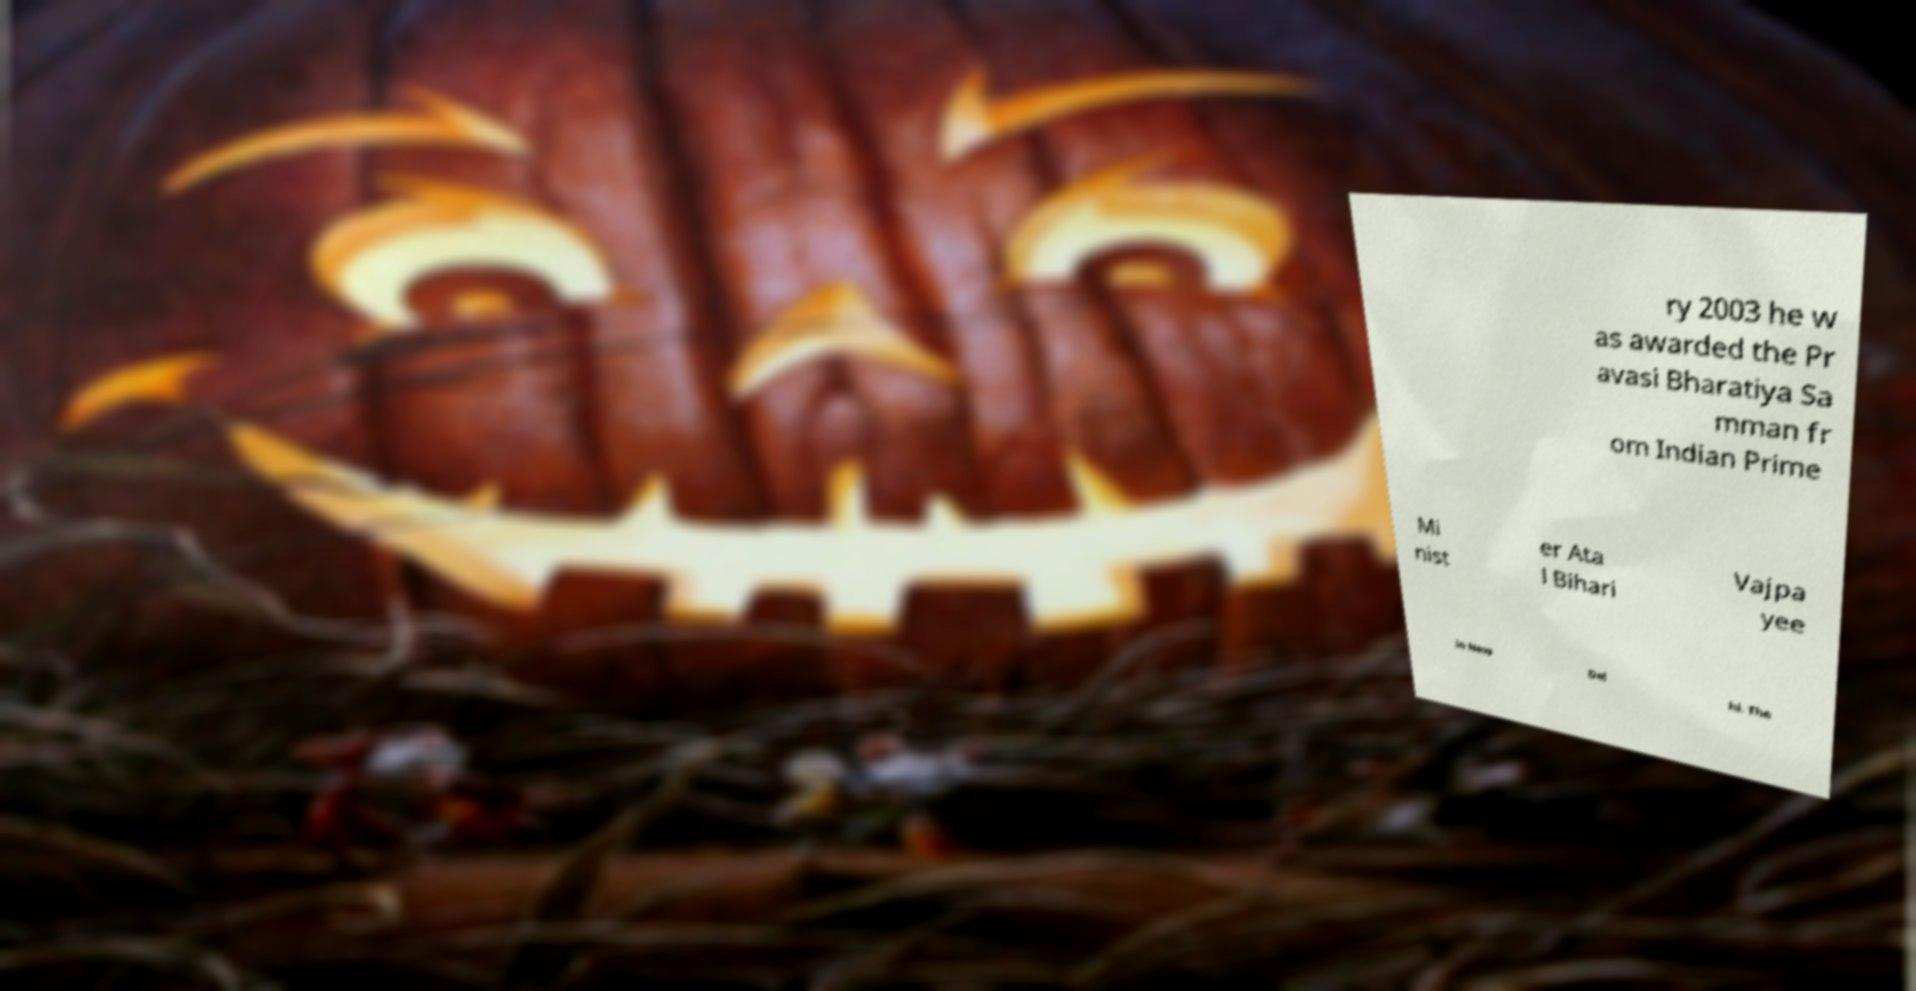Can you read and provide the text displayed in the image?This photo seems to have some interesting text. Can you extract and type it out for me? ry 2003 he w as awarded the Pr avasi Bharatiya Sa mman fr om Indian Prime Mi nist er Ata l Bihari Vajpa yee in New Del hi. The 